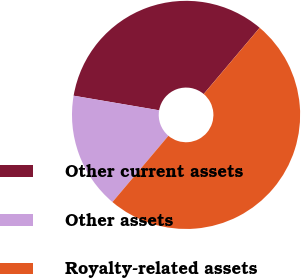Convert chart. <chart><loc_0><loc_0><loc_500><loc_500><pie_chart><fcel>Other current assets<fcel>Other assets<fcel>Royalty-related assets<nl><fcel>33.47%<fcel>16.53%<fcel>50.0%<nl></chart> 